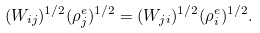<formula> <loc_0><loc_0><loc_500><loc_500>( W _ { i j } ) ^ { 1 / 2 } ( \rho ^ { e } _ { j } ) ^ { 1 / 2 } = ( W _ { j i } ) ^ { 1 / 2 } ( \rho ^ { e } _ { i } ) ^ { 1 / 2 } .</formula> 